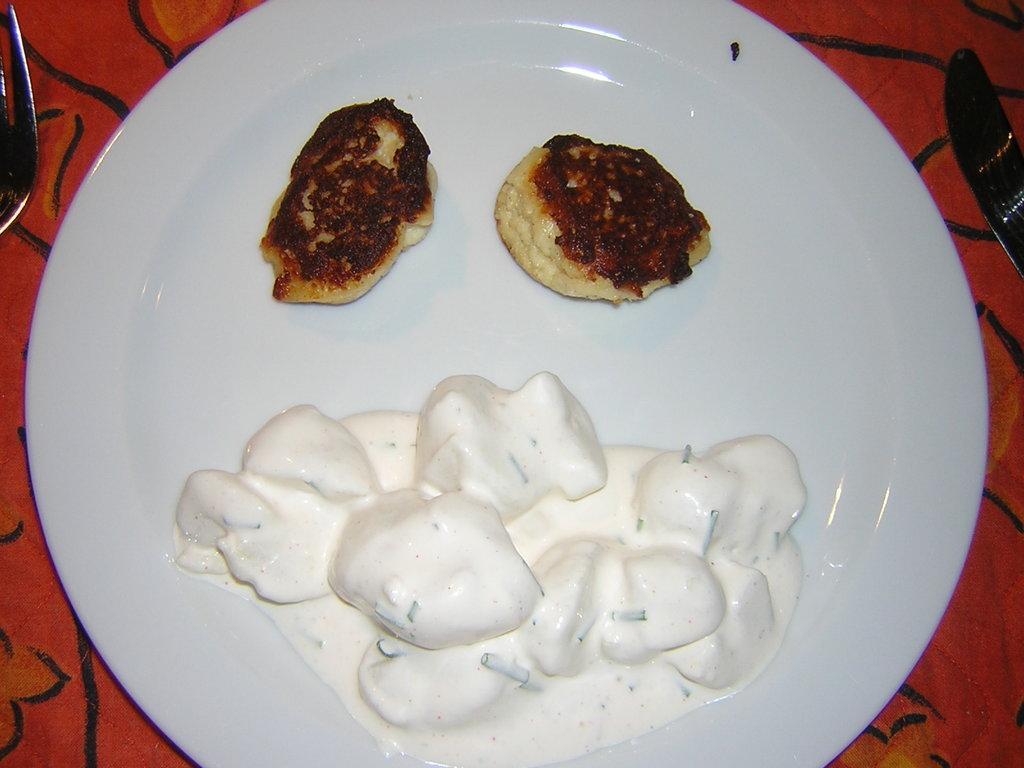In one or two sentences, can you explain what this image depicts? In this image I can see a white color plate kept on the table , on the table I can see two forks and top of the I can see food. 